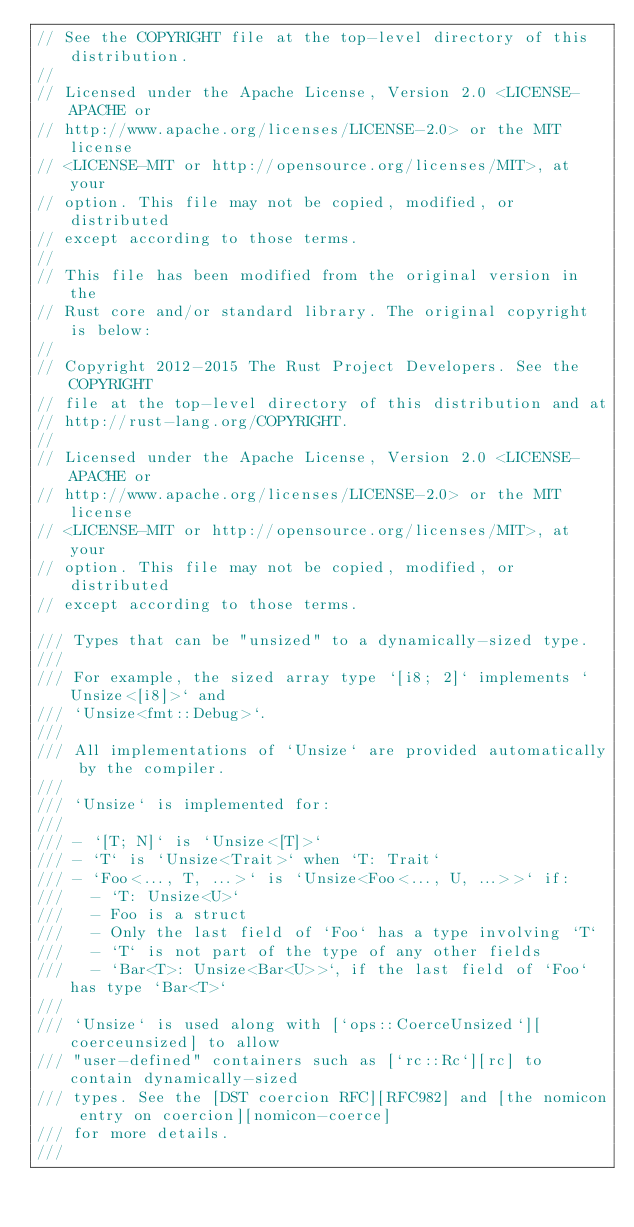<code> <loc_0><loc_0><loc_500><loc_500><_Rust_>// See the COPYRIGHT file at the top-level directory of this distribution.
//
// Licensed under the Apache License, Version 2.0 <LICENSE-APACHE or
// http://www.apache.org/licenses/LICENSE-2.0> or the MIT license
// <LICENSE-MIT or http://opensource.org/licenses/MIT>, at your
// option. This file may not be copied, modified, or distributed
// except according to those terms.
//
// This file has been modified from the original version in the
// Rust core and/or standard library. The original copyright is below:
//
// Copyright 2012-2015 The Rust Project Developers. See the COPYRIGHT
// file at the top-level directory of this distribution and at
// http://rust-lang.org/COPYRIGHT.
//
// Licensed under the Apache License, Version 2.0 <LICENSE-APACHE or
// http://www.apache.org/licenses/LICENSE-2.0> or the MIT license
// <LICENSE-MIT or http://opensource.org/licenses/MIT>, at your
// option. This file may not be copied, modified, or distributed
// except according to those terms.

/// Types that can be "unsized" to a dynamically-sized type.
///
/// For example, the sized array type `[i8; 2]` implements `Unsize<[i8]>` and
/// `Unsize<fmt::Debug>`.
///
/// All implementations of `Unsize` are provided automatically by the compiler.
///
/// `Unsize` is implemented for:
///
/// - `[T; N]` is `Unsize<[T]>`
/// - `T` is `Unsize<Trait>` when `T: Trait`
/// - `Foo<..., T, ...>` is `Unsize<Foo<..., U, ...>>` if:
///   - `T: Unsize<U>`
///   - Foo is a struct
///   - Only the last field of `Foo` has a type involving `T`
///   - `T` is not part of the type of any other fields
///   - `Bar<T>: Unsize<Bar<U>>`, if the last field of `Foo` has type `Bar<T>`
///
/// `Unsize` is used along with [`ops::CoerceUnsized`][coerceunsized] to allow
/// "user-defined" containers such as [`rc::Rc`][rc] to contain dynamically-sized
/// types. See the [DST coercion RFC][RFC982] and [the nomicon entry on coercion][nomicon-coerce]
/// for more details.
///</code> 